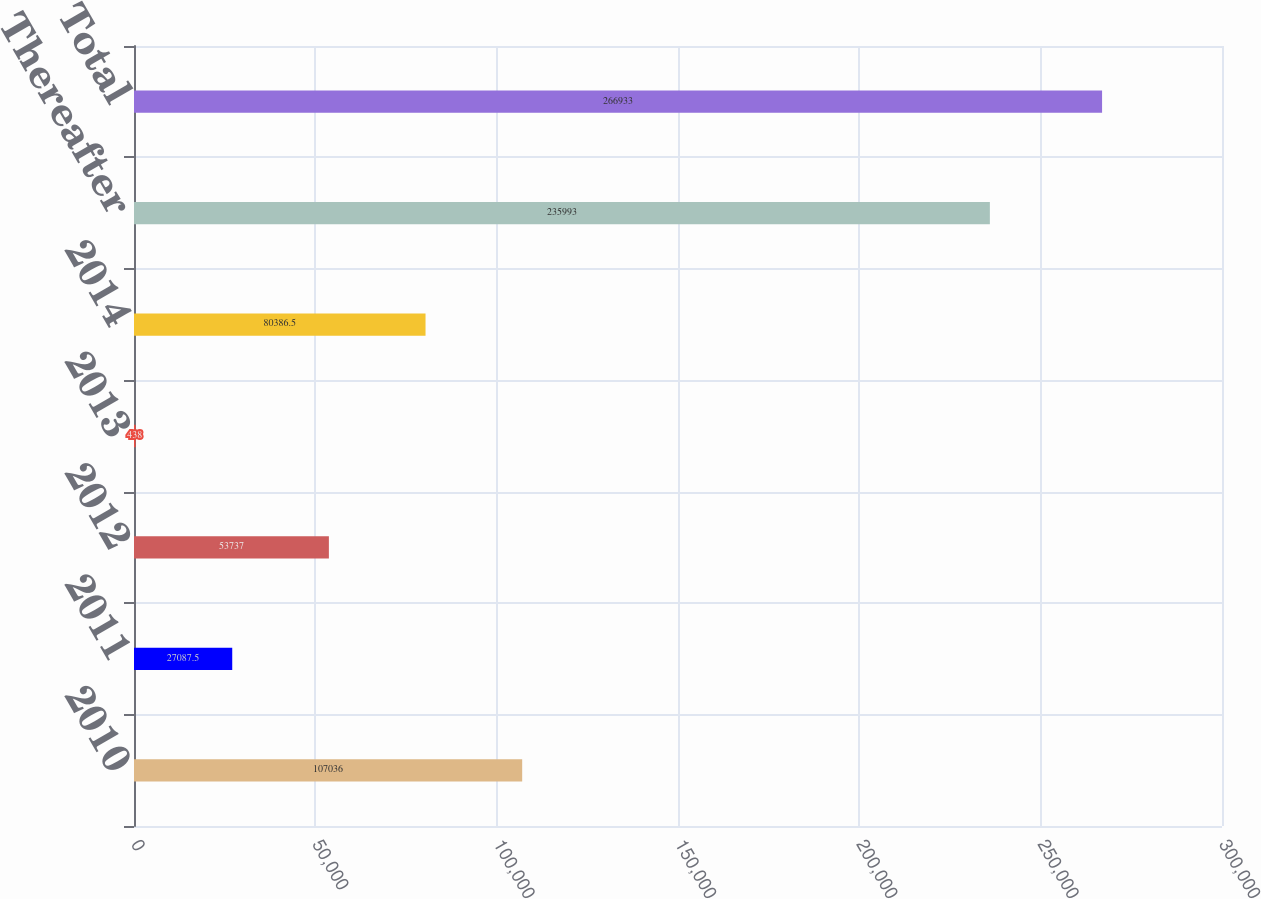Convert chart. <chart><loc_0><loc_0><loc_500><loc_500><bar_chart><fcel>2010<fcel>2011<fcel>2012<fcel>2013<fcel>2014<fcel>Thereafter<fcel>Total<nl><fcel>107036<fcel>27087.5<fcel>53737<fcel>438<fcel>80386.5<fcel>235993<fcel>266933<nl></chart> 